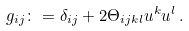Convert formula to latex. <formula><loc_0><loc_0><loc_500><loc_500>g _ { i j } \colon = \delta _ { i j } + 2 \Theta _ { i j k l } u ^ { k } u ^ { l } \, .</formula> 